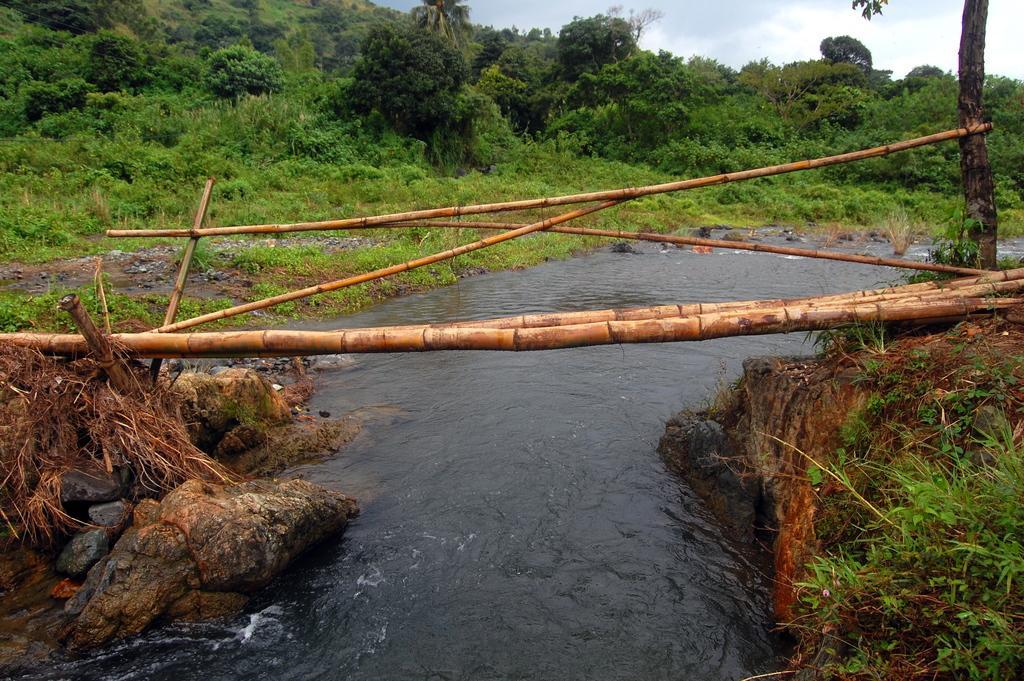Please provide a concise description of this image. Here we can see water. Background there are plants and trees. 